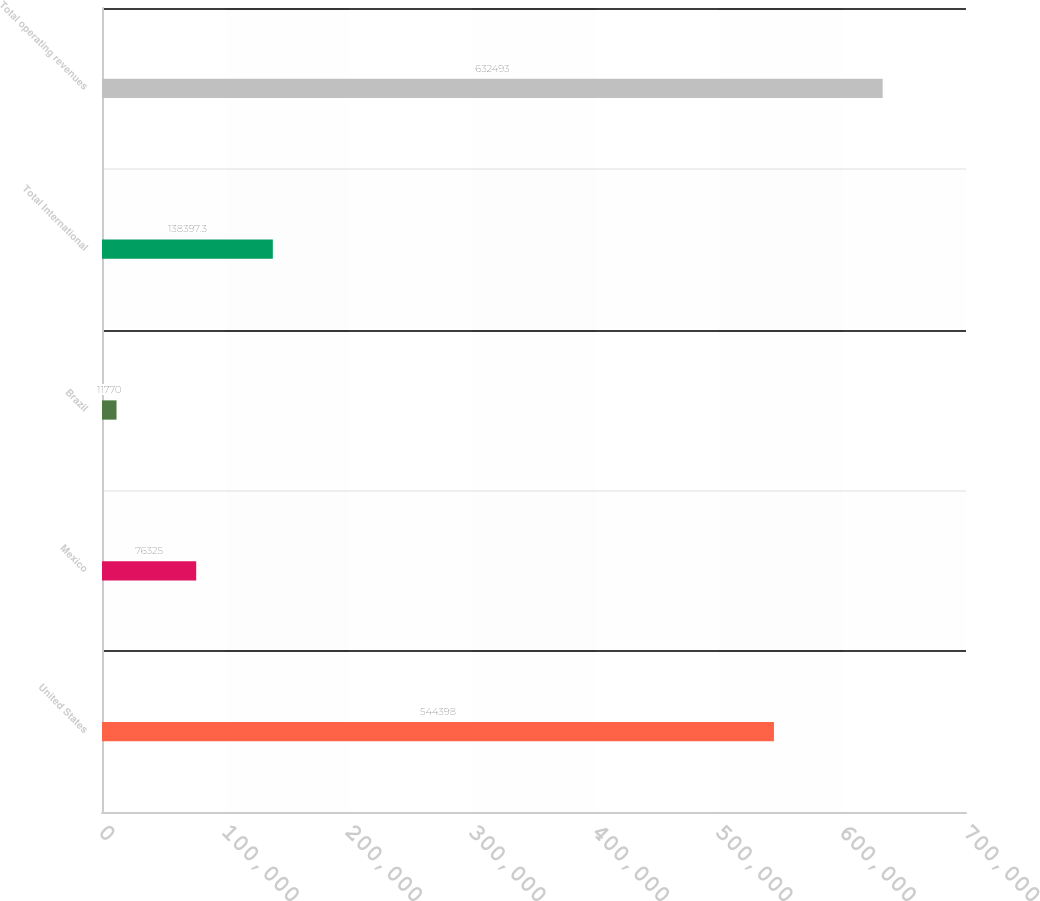Convert chart. <chart><loc_0><loc_0><loc_500><loc_500><bar_chart><fcel>United States<fcel>Mexico<fcel>Brazil<fcel>Total International<fcel>Total operating revenues<nl><fcel>544398<fcel>76325<fcel>11770<fcel>138397<fcel>632493<nl></chart> 